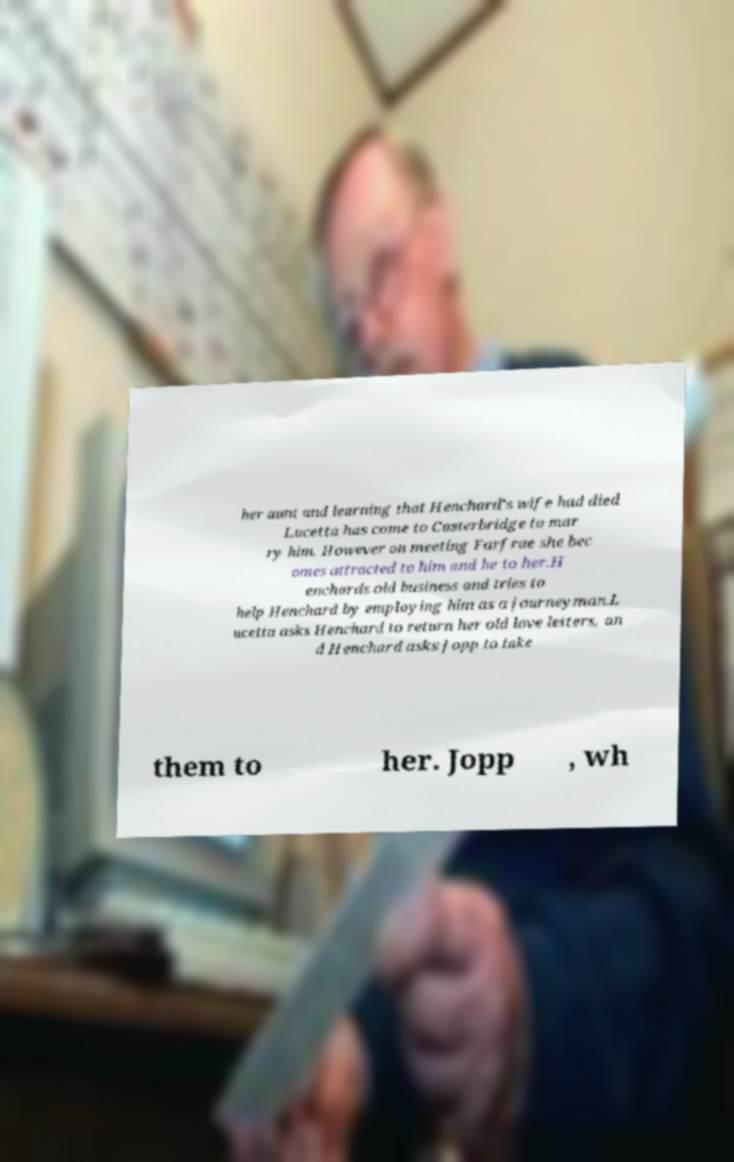I need the written content from this picture converted into text. Can you do that? her aunt and learning that Henchard's wife had died Lucetta has come to Casterbridge to mar ry him. However on meeting Farfrae she bec omes attracted to him and he to her.H enchards old business and tries to help Henchard by employing him as a journeyman.L ucetta asks Henchard to return her old love letters, an d Henchard asks Jopp to take them to her. Jopp , wh 